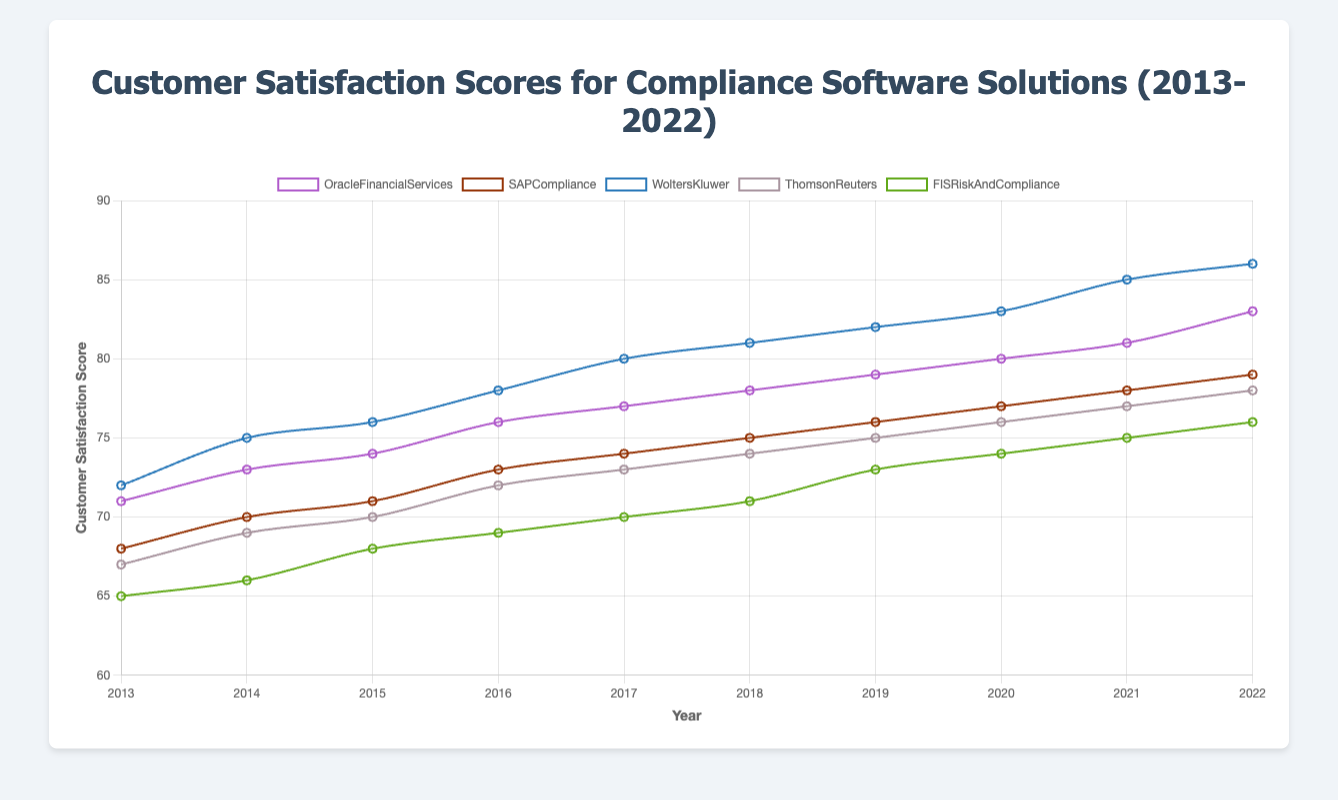what was the highest customer satisfaction score for Wolters Kluwer, and in what year was it achieved? To find the answer, look at the data points for Wolters Kluwer and identify the peak value. The highest score is 86, achieved in 2022.
Answer: 86 in 2022 Between SAP Compliance and Thomson Reuters, which software solution had higher customer satisfaction in 2020, and by how much? Compare the scores for SAP Compliance (77) and Thomson Reuters (76) in 2020. SAP Compliance had a higher score by 1 point.
Answer: SAP Compliance by 1 What is the average customer satisfaction score of FIS Risk And Compliance for the years 2013-2015? Add the scores of FIS Risk And Compliance for 2013, 2014, and 2015 (65, 66, 68), and divide by the number of years: (65 + 66 + 68) / 3 = 66.33.
Answer: 66.33 Which software solution showed the most consistent increase in customer satisfaction over the decade? By examining the data points year by year, Wolters Kluwer shows a consistently increasing trend without any dips, from 72 in 2013 to 86 in 2022.
Answer: Wolters Kluwer In which year did Oracle Financial Services see the largest year-over-year increase in customer satisfaction score, and what was the increase? Identify year-over-year increases and find the largest. From 2015 to 2016, Oracle Financial Services increased from 74 to 76, a 2-point increase.
Answer: 2016, 2 points What is the difference in the customer satisfaction score for SAP Compliance between 2017 and 2022? Subtract the 2017 score from the 2022 score for SAP Compliance (79 - 74 = 5).
Answer: 5 points Which software solution had the lowest customer satisfaction score in 2013, and what was the score? Compare all scores for 2013 and identify the lowest one, which is FIS Risk And Compliance with a score of 65.
Answer: FIS Risk And Compliance, 65 If you sum the customer satisfaction scores for all software solutions in 2019, what is the total? Add the 2019 scores: 79 (Oracle) + 76 (SAP) + 82 (Wolters Kluwer) + 75 (Thomson Reuters) + 73 (FIS) = 385.
Answer: 385 By how many points did the customer satisfaction score for Thomson Reuters improve from 2018 to 2022? Subtract the 2018 score from the 2022 score for Thomson Reuters (78 - 74 = 4).
Answer: 4 points 